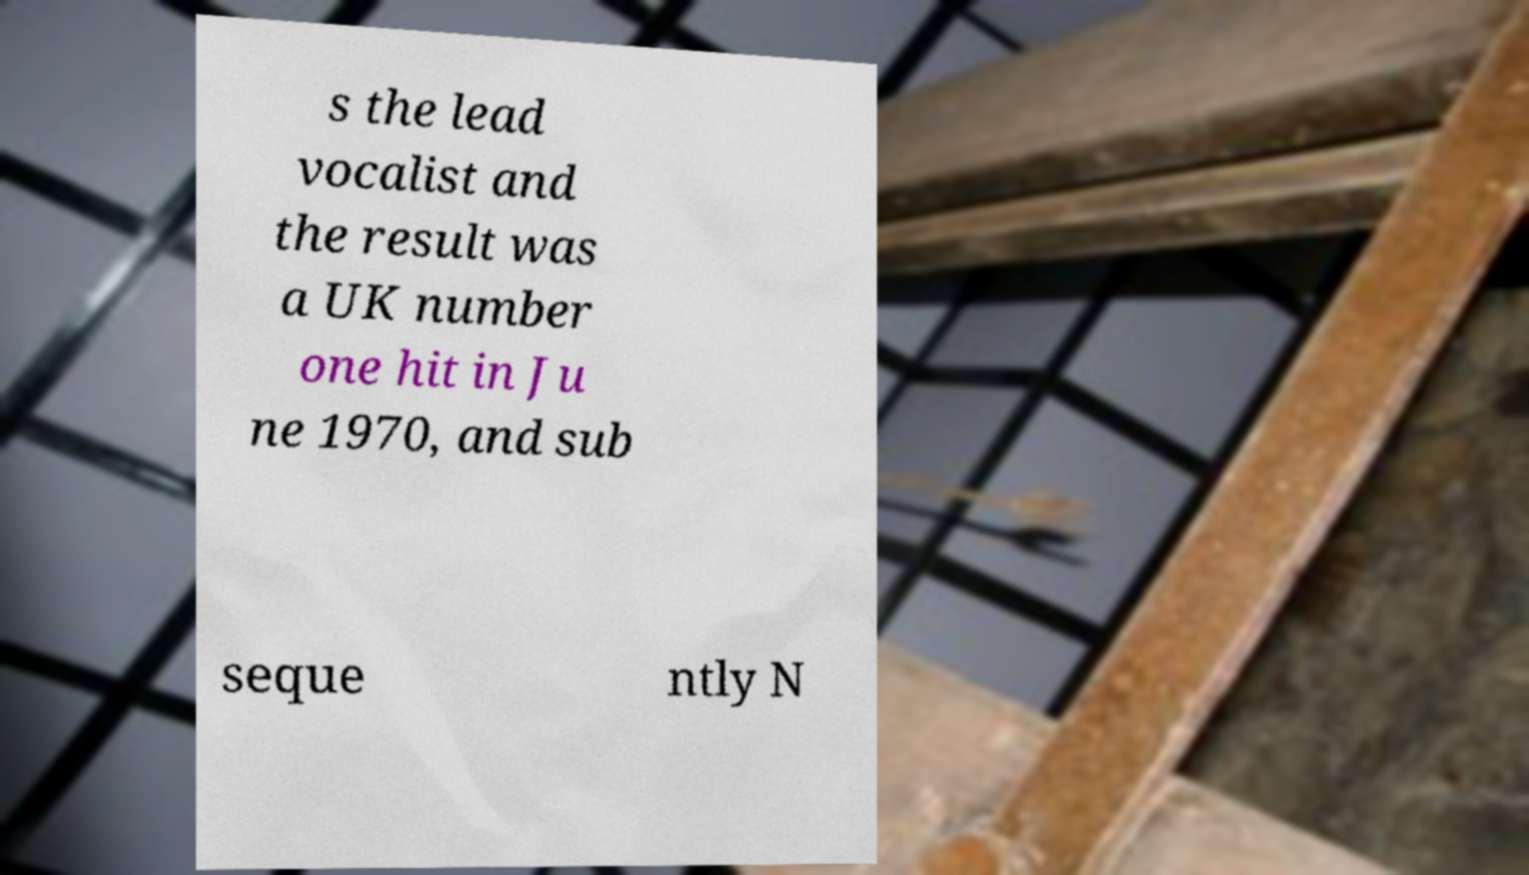There's text embedded in this image that I need extracted. Can you transcribe it verbatim? s the lead vocalist and the result was a UK number one hit in Ju ne 1970, and sub seque ntly N 